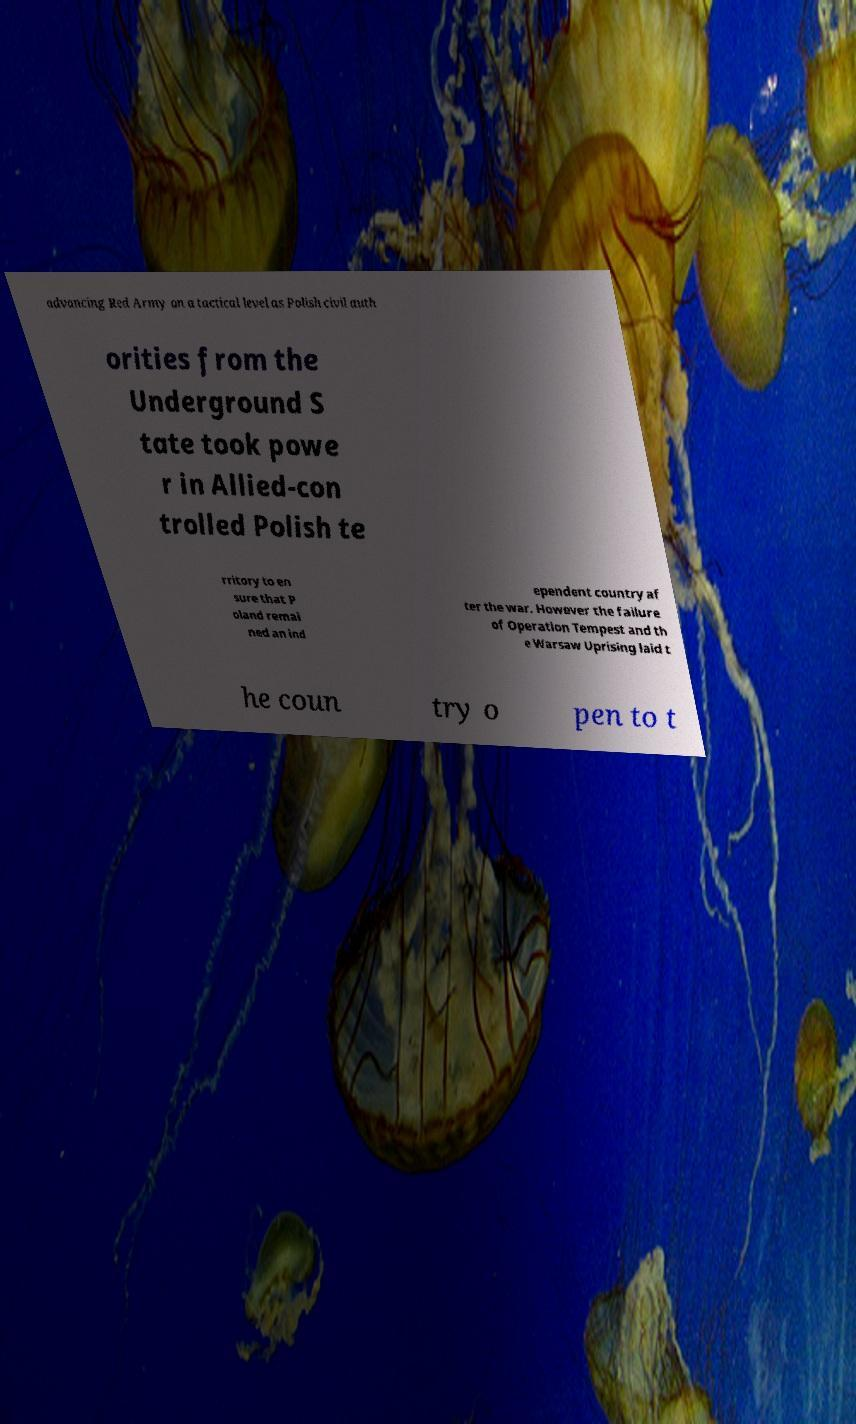For documentation purposes, I need the text within this image transcribed. Could you provide that? advancing Red Army on a tactical level as Polish civil auth orities from the Underground S tate took powe r in Allied-con trolled Polish te rritory to en sure that P oland remai ned an ind ependent country af ter the war. However the failure of Operation Tempest and th e Warsaw Uprising laid t he coun try o pen to t 